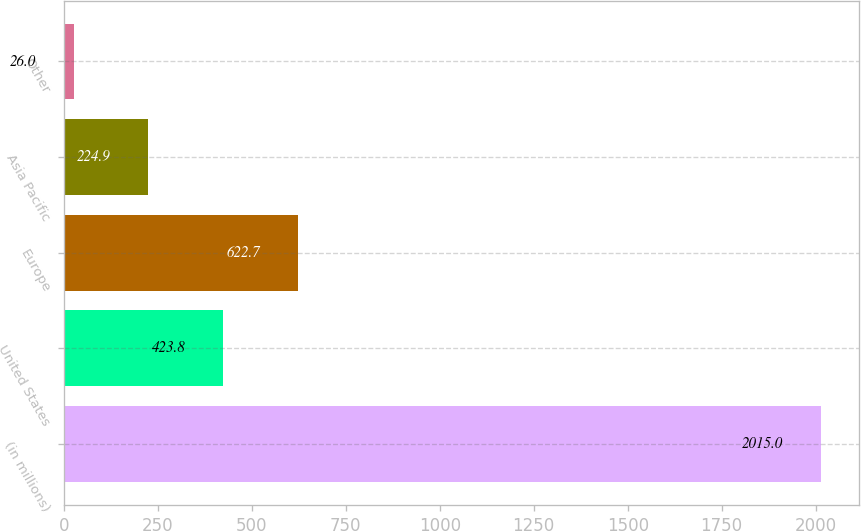<chart> <loc_0><loc_0><loc_500><loc_500><bar_chart><fcel>(in millions)<fcel>United States<fcel>Europe<fcel>Asia Pacific<fcel>Other<nl><fcel>2015<fcel>423.8<fcel>622.7<fcel>224.9<fcel>26<nl></chart> 